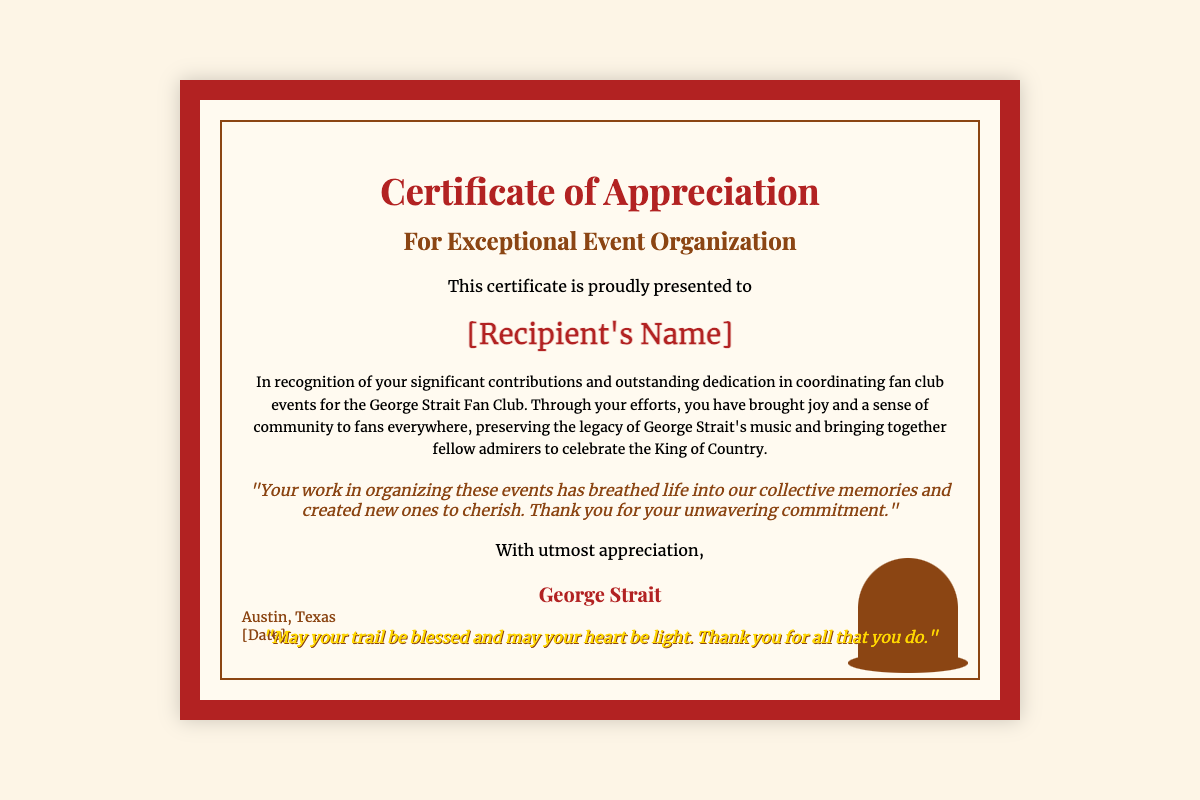What is the title of the certificate? The title of the certificate is prominently displayed at the top, stating what the certificate is for.
Answer: Certificate of Appreciation Who is the recipient of the certificate? The recipient's name is a placeholder in the document, indicating where the actual name will go.
Answer: [Recipient's Name] What is the main purpose of the certificate? The main purpose is described in the second header, highlighting the reason for the award.
Answer: Exceptional Event Organization Where is the certificate issued? The location where the certificate is presented is mentioned at the bottom of the document.
Answer: Austin, Texas What personal note does George Strait include? The personal note expresses gratitude and recognition for the recipient’s efforts in organizing events.
Answer: "Your work in organizing these events has breathed life into our collective memories and created new ones to cherish. Thank you for your unwavering commitment." What quote is attributed to George Strait? The quote reflects a positive sentiment and appreciation for the recipient's work.
Answer: "May your trail be blessed and may your heart be light. Thank you for all that you do." What design element represents a Texas cowboy aesthetic? The document's design includes specific visuals that evoke Texas cowboy culture.
Answer: Cowboy hat How many colors are dominant in the border design? The border design features two prominent colors that frame the certificate.
Answer: Two What font style is used for the title? The document specifies different font styles for various text elements, with a specific style for the title.
Answer: Playfair Display 